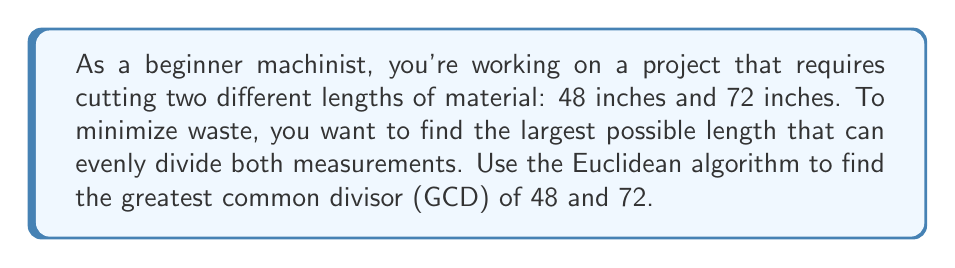Help me with this question. Let's apply the Euclidean algorithm to find the GCD of 48 and 72:

1) First, set up the initial equation:
   $72 = 1 \cdot 48 + 24$

2) Now, we use the remainder (24) and divide the smaller number (48) by it:
   $48 = 2 \cdot 24 + 0$

3) We've reached a remainder of 0, so we stop here. The last non-zero remainder is our GCD.

Therefore, the GCD of 48 and 72 is 24.

To verify:
$48 = 2 \cdot 24$
$72 = 3 \cdot 24$

This means that 24 inches is the largest length that can evenly divide both 48 inches and 72 inches, which will help minimize waste in your machining project.
Answer: 24 